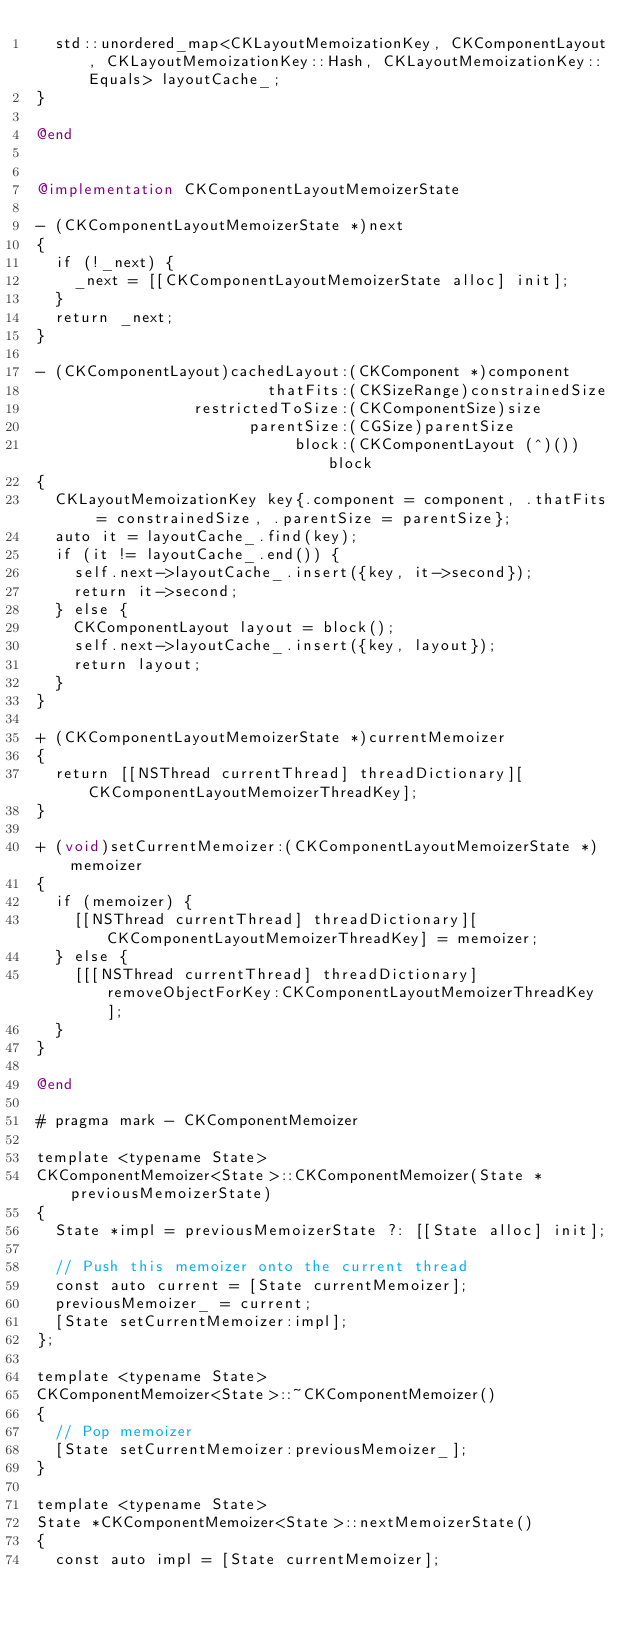Convert code to text. <code><loc_0><loc_0><loc_500><loc_500><_ObjectiveC_>  std::unordered_map<CKLayoutMemoizationKey, CKComponentLayout, CKLayoutMemoizationKey::Hash, CKLayoutMemoizationKey::Equals> layoutCache_;
}

@end


@implementation CKComponentLayoutMemoizerState

- (CKComponentLayoutMemoizerState *)next
{
  if (!_next) {
    _next = [[CKComponentLayoutMemoizerState alloc] init];
  }
  return _next;
}

- (CKComponentLayout)cachedLayout:(CKComponent *)component
                         thatFits:(CKSizeRange)constrainedSize
                 restrictedToSize:(CKComponentSize)size
                       parentSize:(CGSize)parentSize
                            block:(CKComponentLayout (^)())block
{
  CKLayoutMemoizationKey key{.component = component, .thatFits = constrainedSize, .parentSize = parentSize};
  auto it = layoutCache_.find(key);
  if (it != layoutCache_.end()) {
    self.next->layoutCache_.insert({key, it->second});
    return it->second;
  } else {
    CKComponentLayout layout = block();
    self.next->layoutCache_.insert({key, layout});
    return layout;
  }
}

+ (CKComponentLayoutMemoizerState *)currentMemoizer
{
  return [[NSThread currentThread] threadDictionary][CKComponentLayoutMemoizerThreadKey];
}

+ (void)setCurrentMemoizer:(CKComponentLayoutMemoizerState *)memoizer
{
  if (memoizer) {
    [[NSThread currentThread] threadDictionary][CKComponentLayoutMemoizerThreadKey] = memoizer;
  } else {
    [[[NSThread currentThread] threadDictionary] removeObjectForKey:CKComponentLayoutMemoizerThreadKey];
  }
}

@end

# pragma mark - CKComponentMemoizer

template <typename State>
CKComponentMemoizer<State>::CKComponentMemoizer(State *previousMemoizerState)
{
  State *impl = previousMemoizerState ?: [[State alloc] init];

  // Push this memoizer onto the current thread
  const auto current = [State currentMemoizer];
  previousMemoizer_ = current;
  [State setCurrentMemoizer:impl];
};

template <typename State>
CKComponentMemoizer<State>::~CKComponentMemoizer()
{
  // Pop memoizer
  [State setCurrentMemoizer:previousMemoizer_];
}

template <typename State>
State *CKComponentMemoizer<State>::nextMemoizerState()
{
  const auto impl = [State currentMemoizer];</code> 